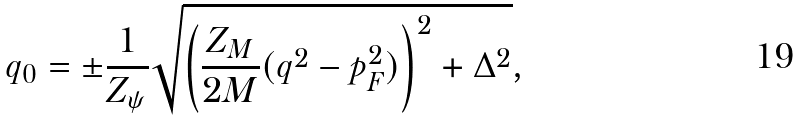Convert formula to latex. <formula><loc_0><loc_0><loc_500><loc_500>q _ { 0 } = \pm \frac { 1 } { Z _ { \psi } } \sqrt { \left ( \frac { Z _ { M } } { 2 M } ( q ^ { 2 } - p _ { F } ^ { 2 } ) \right ) ^ { 2 } + \Delta ^ { 2 } } ,</formula> 